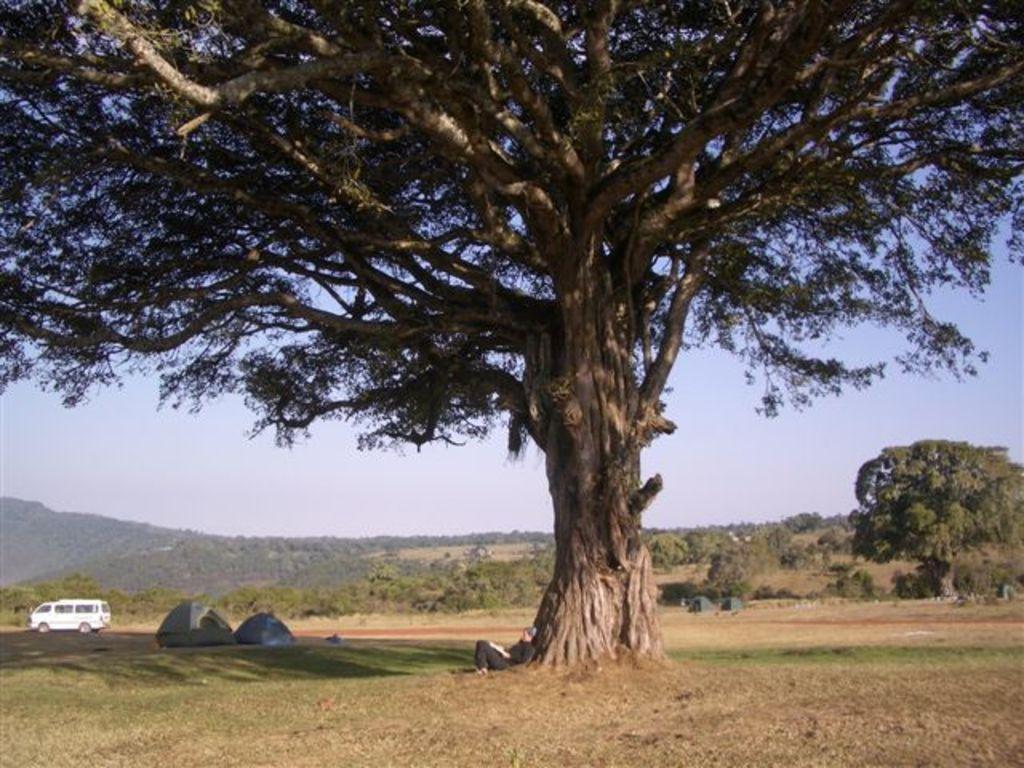How would you summarize this image in a sentence or two? In this image I can see trees, huts and a car on the ground. In the background I can see the sky and mountains. This image is taken during a day. 